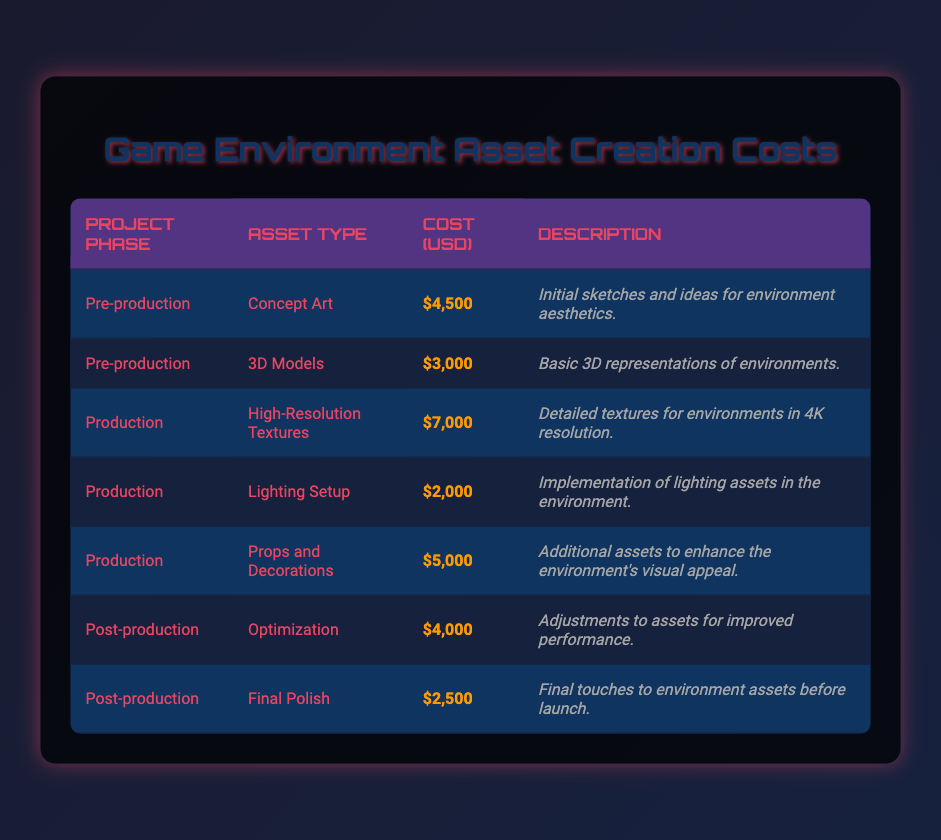What is the total cost for assets during the Production phase? The Production phase has three asset types: High-Resolution Textures for 7000, Lighting Setup for 2000, and Props and Decorations for 5000. Adding these costs together: 7000 + 2000 + 5000 = 14000.
Answer: 14000 Which asset type has the highest cost in the entire table? Looking through the costs, the highest is High-Resolution Textures at 7000.
Answer: High-Resolution Textures Is the cost of Optimization higher than that of Final Polish? Optimization costs 4000 and Final Polish costs 2500, so yes, 4000 is greater than 2500.
Answer: Yes What is the average cost for assets in the Pre-production phase? There are two asset types: Concept Art for 4500 and 3D Models for 3000. Summing these gives 4500 + 3000 = 7500, and dividing by 2 for the average results in 7500 / 2 = 3750.
Answer: 3750 How much less does Lighting Setup cost compared to Props and Decorations? Lighting Setup costs 2000 and Props and Decorations costs 5000. The difference is 5000 - 2000 = 3000.
Answer: 3000 Which project phase has a higher total cost, Pre-production or Post-production? Pre-production has a total cost of 4500 + 3000 = 7500, while Post-production has a total of 4000 + 2500 = 6500. Comparing both totals, 7500 is greater than 6500.
Answer: Pre-production Is there an asset type in the Production phase that costs less than 3000? The costs for Production assets are 7000, 2000, and 5000. One asset, Lighting Setup, costs 2000, which is less than 3000.
Answer: Yes What is the total cost for all assets listed in the table? Adding all values together gives: 4500 + 3000 + 7000 + 2000 + 5000 + 4000 + 2500 = 28000.
Answer: 28000 